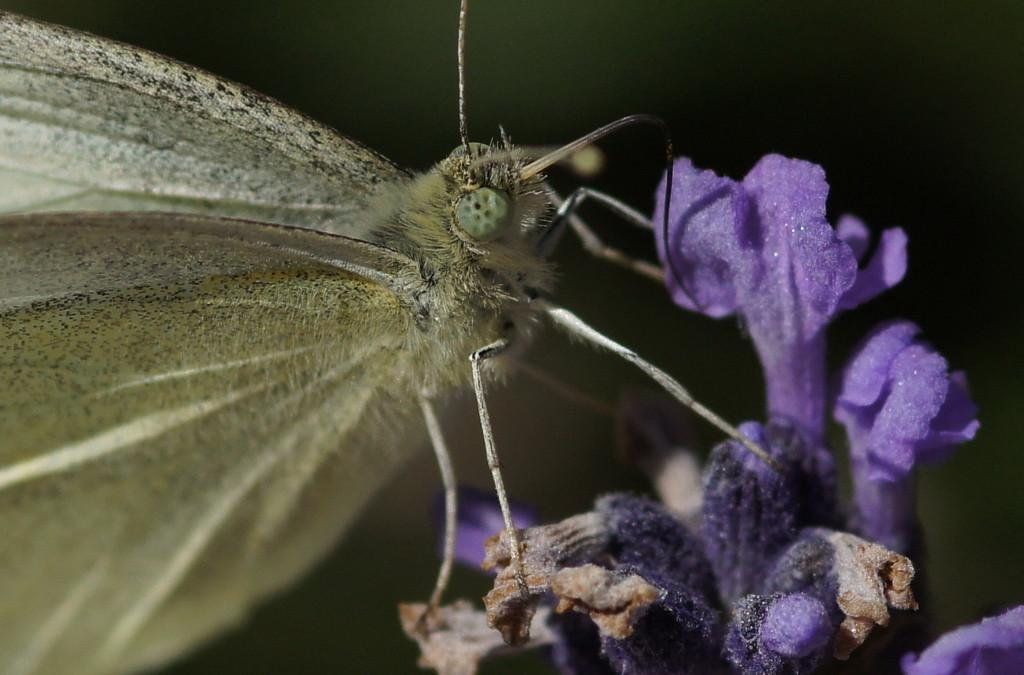What type of living organism can be seen in the image? There is an insect in the image. What type of plant is visible in the image? There is a flower in the image. What type of memory is stored in the flower in the image? There is no indication that the flower in the image has any memory, as plants do not have the ability to store memories. 